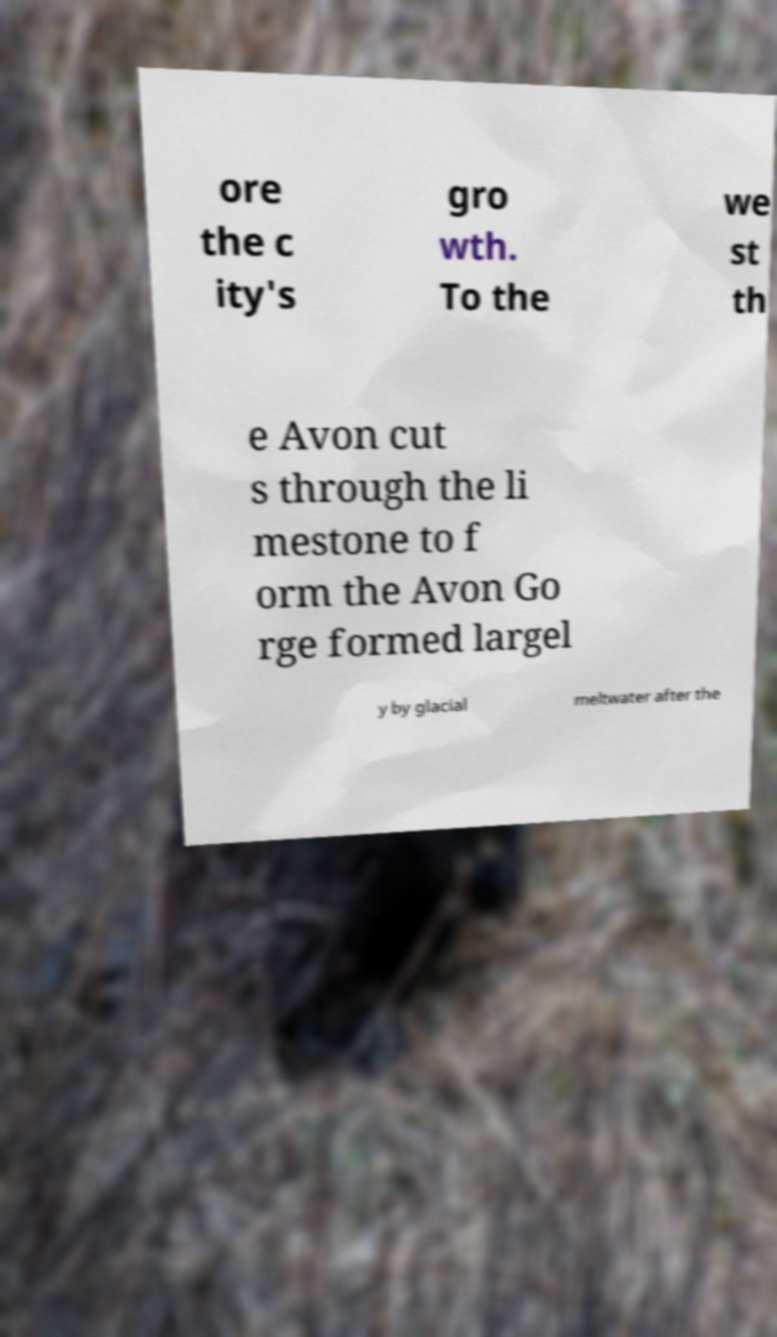There's text embedded in this image that I need extracted. Can you transcribe it verbatim? ore the c ity's gro wth. To the we st th e Avon cut s through the li mestone to f orm the Avon Go rge formed largel y by glacial meltwater after the 